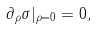Convert formula to latex. <formula><loc_0><loc_0><loc_500><loc_500>\partial _ { \rho } \sigma | _ { \rho = 0 } = 0 ,</formula> 